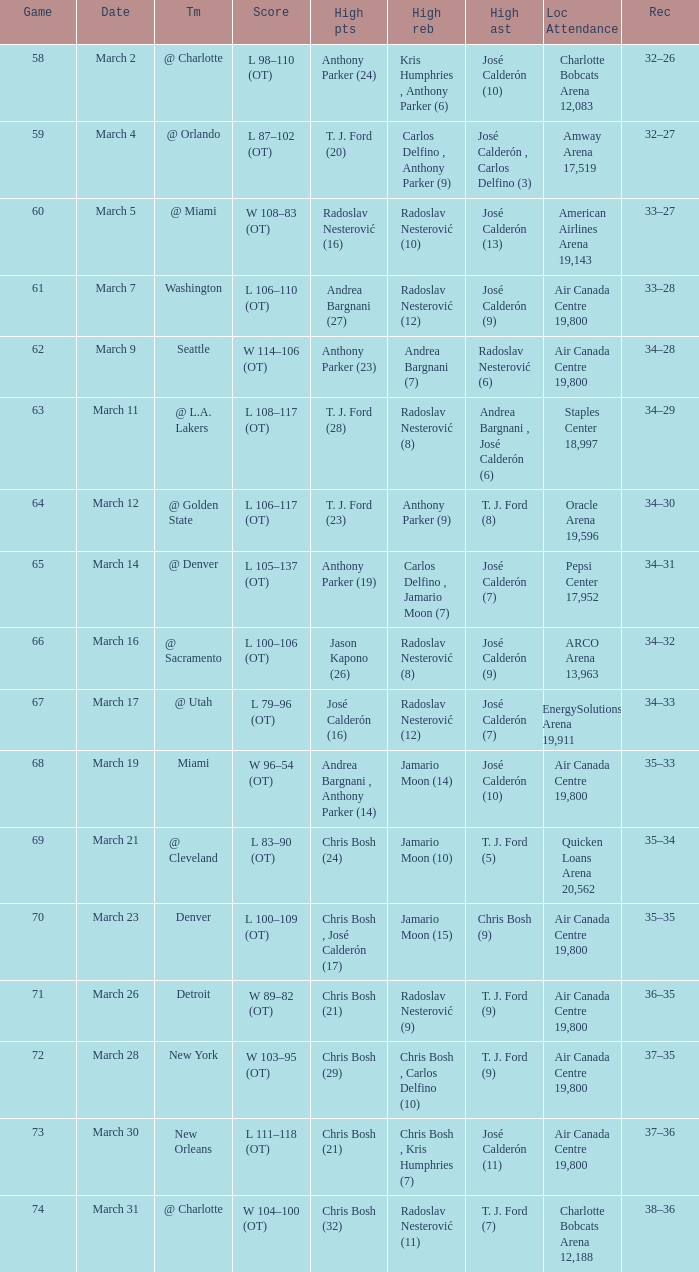How many attended the game on march 16 after over 64 games? ARCO Arena 13,963. Would you be able to parse every entry in this table? {'header': ['Game', 'Date', 'Tm', 'Score', 'High pts', 'High reb', 'High ast', 'Loc Attendance', 'Rec'], 'rows': [['58', 'March 2', '@ Charlotte', 'L 98–110 (OT)', 'Anthony Parker (24)', 'Kris Humphries , Anthony Parker (6)', 'José Calderón (10)', 'Charlotte Bobcats Arena 12,083', '32–26'], ['59', 'March 4', '@ Orlando', 'L 87–102 (OT)', 'T. J. Ford (20)', 'Carlos Delfino , Anthony Parker (9)', 'José Calderón , Carlos Delfino (3)', 'Amway Arena 17,519', '32–27'], ['60', 'March 5', '@ Miami', 'W 108–83 (OT)', 'Radoslav Nesterović (16)', 'Radoslav Nesterović (10)', 'José Calderón (13)', 'American Airlines Arena 19,143', '33–27'], ['61', 'March 7', 'Washington', 'L 106–110 (OT)', 'Andrea Bargnani (27)', 'Radoslav Nesterović (12)', 'José Calderón (9)', 'Air Canada Centre 19,800', '33–28'], ['62', 'March 9', 'Seattle', 'W 114–106 (OT)', 'Anthony Parker (23)', 'Andrea Bargnani (7)', 'Radoslav Nesterović (6)', 'Air Canada Centre 19,800', '34–28'], ['63', 'March 11', '@ L.A. Lakers', 'L 108–117 (OT)', 'T. J. Ford (28)', 'Radoslav Nesterović (8)', 'Andrea Bargnani , José Calderón (6)', 'Staples Center 18,997', '34–29'], ['64', 'March 12', '@ Golden State', 'L 106–117 (OT)', 'T. J. Ford (23)', 'Anthony Parker (9)', 'T. J. Ford (8)', 'Oracle Arena 19,596', '34–30'], ['65', 'March 14', '@ Denver', 'L 105–137 (OT)', 'Anthony Parker (19)', 'Carlos Delfino , Jamario Moon (7)', 'José Calderón (7)', 'Pepsi Center 17,952', '34–31'], ['66', 'March 16', '@ Sacramento', 'L 100–106 (OT)', 'Jason Kapono (26)', 'Radoslav Nesterović (8)', 'José Calderón (9)', 'ARCO Arena 13,963', '34–32'], ['67', 'March 17', '@ Utah', 'L 79–96 (OT)', 'José Calderón (16)', 'Radoslav Nesterović (12)', 'José Calderón (7)', 'EnergySolutions Arena 19,911', '34–33'], ['68', 'March 19', 'Miami', 'W 96–54 (OT)', 'Andrea Bargnani , Anthony Parker (14)', 'Jamario Moon (14)', 'José Calderón (10)', 'Air Canada Centre 19,800', '35–33'], ['69', 'March 21', '@ Cleveland', 'L 83–90 (OT)', 'Chris Bosh (24)', 'Jamario Moon (10)', 'T. J. Ford (5)', 'Quicken Loans Arena 20,562', '35–34'], ['70', 'March 23', 'Denver', 'L 100–109 (OT)', 'Chris Bosh , José Calderón (17)', 'Jamario Moon (15)', 'Chris Bosh (9)', 'Air Canada Centre 19,800', '35–35'], ['71', 'March 26', 'Detroit', 'W 89–82 (OT)', 'Chris Bosh (21)', 'Radoslav Nesterović (9)', 'T. J. Ford (9)', 'Air Canada Centre 19,800', '36–35'], ['72', 'March 28', 'New York', 'W 103–95 (OT)', 'Chris Bosh (29)', 'Chris Bosh , Carlos Delfino (10)', 'T. J. Ford (9)', 'Air Canada Centre 19,800', '37–35'], ['73', 'March 30', 'New Orleans', 'L 111–118 (OT)', 'Chris Bosh (21)', 'Chris Bosh , Kris Humphries (7)', 'José Calderón (11)', 'Air Canada Centre 19,800', '37–36'], ['74', 'March 31', '@ Charlotte', 'W 104–100 (OT)', 'Chris Bosh (32)', 'Radoslav Nesterović (11)', 'T. J. Ford (7)', 'Charlotte Bobcats Arena 12,188', '38–36']]} 